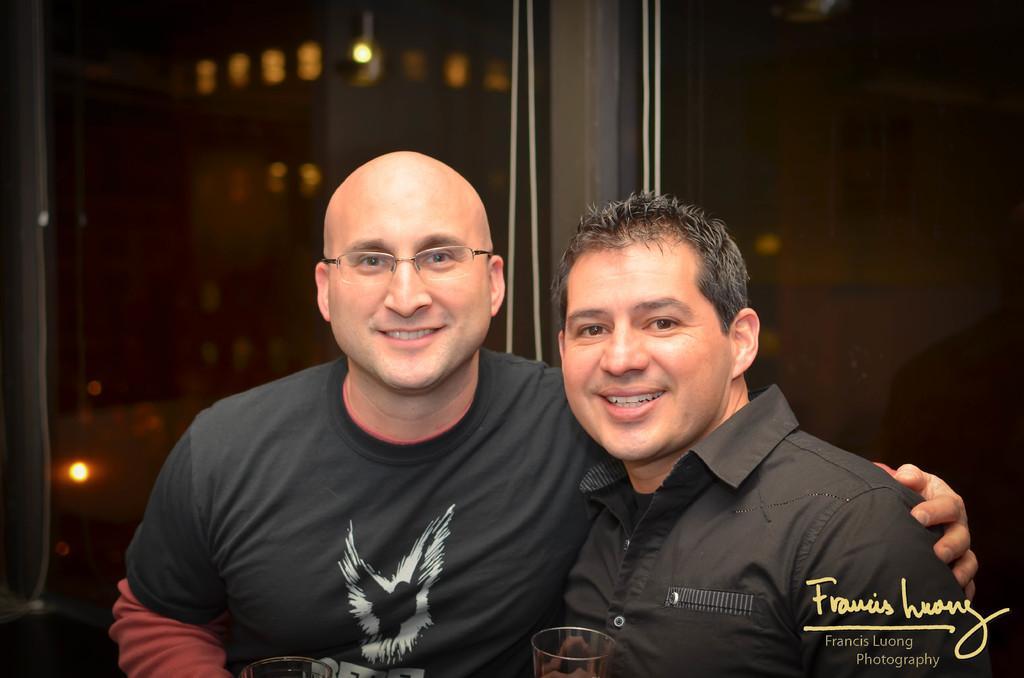How would you summarize this image in a sentence or two? In this image I can see a man is smiling by placing his hand on another man. He wore black color t-shirt, this man is also smiling. Behind them there is the glass wall and there are lights in it, at the bottom there is the water mark. 